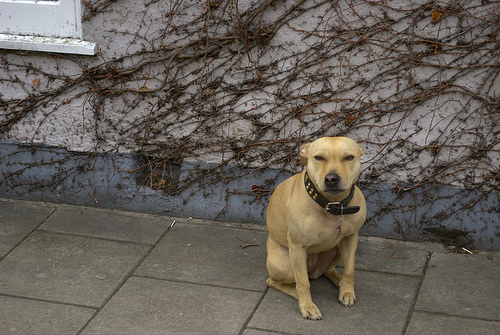Is the collar on a dog? Yes, the collar is indeed on a dog, specifically a tan-colored one sitting obediently, adorned with a dark, buckled collar. 